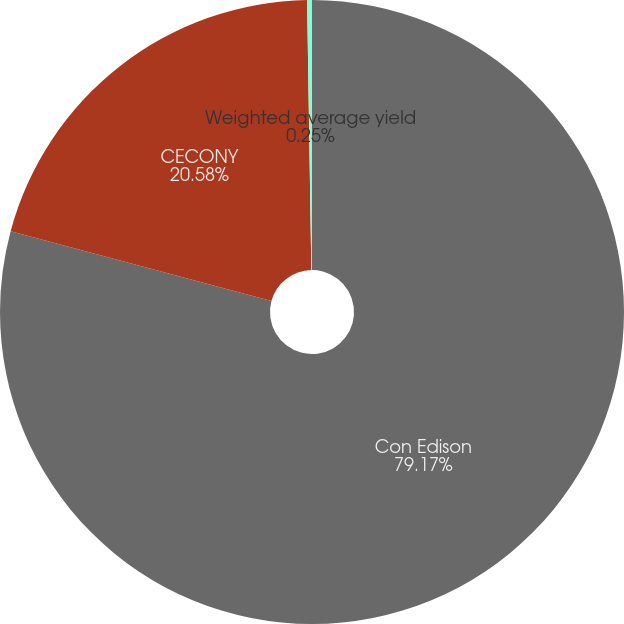<chart> <loc_0><loc_0><loc_500><loc_500><pie_chart><fcel>Con Edison<fcel>CECONY<fcel>Weighted average yield<nl><fcel>79.17%<fcel>20.58%<fcel>0.25%<nl></chart> 